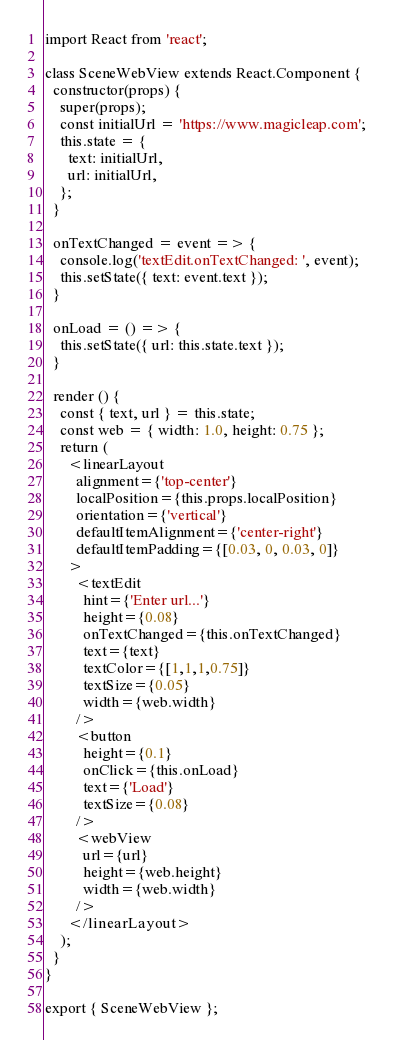<code> <loc_0><loc_0><loc_500><loc_500><_JavaScript_>import React from 'react';

class SceneWebView extends React.Component {
  constructor(props) {
    super(props);
    const initialUrl = 'https://www.magicleap.com';
    this.state = {
      text: initialUrl,
      url: initialUrl,
    };
  }

  onTextChanged = event => {
    console.log('textEdit.onTextChanged: ', event);
    this.setState({ text: event.text });
  }

  onLoad = () => {
    this.setState({ url: this.state.text });
  }

  render () {
    const { text, url } = this.state;
    const web = { width: 1.0, height: 0.75 };
    return (
      <linearLayout 
        alignment={'top-center'}
        localPosition={this.props.localPosition}
        orientation={'vertical'}
        defaultItemAlignment={'center-right'}
        defaultItemPadding={[0.03, 0, 0.03, 0]}
      >
        <textEdit 
          hint={'Enter url...'}
          height={0.08}
          onTextChanged={this.onTextChanged}
          text={text}
          textColor={[1,1,1,0.75]}
          textSize={0.05}
          width={web.width}
        />
        <button 
          height={0.1}
          onClick={this.onLoad}
          text={'Load'}
          textSize={0.08}
        />
        <webView 
          url={url} 
          height={web.height} 
          width={web.width}
        />
      </linearLayout>
    );
  }
}

export { SceneWebView };
</code> 